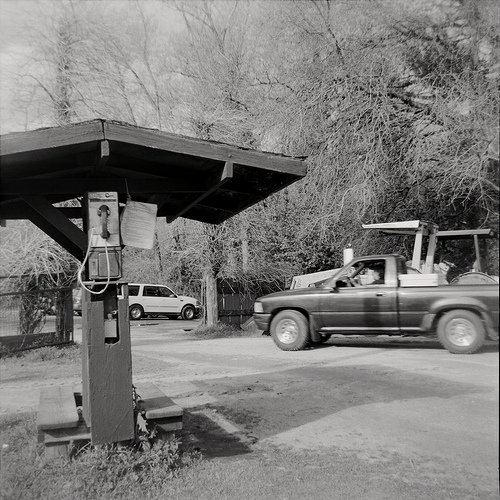Please provide the bounding box coordinate of the region this sentence describes: A small wooden bench. The bounding box for the small wooden bench is at coordinates [0.06, 0.76, 0.17, 0.93]. This box captures the bench situated under the wooden structure in the image. 